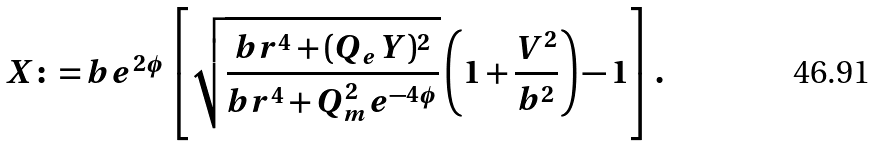<formula> <loc_0><loc_0><loc_500><loc_500>X \colon = b e ^ { 2 \phi } \left [ \sqrt { \frac { b r ^ { 4 } + ( Q _ { e } Y ) ^ { 2 } } { b r ^ { 4 } + Q _ { m } ^ { 2 } e ^ { - 4 \phi } } } \left ( 1 + \frac { V ^ { 2 } } { b ^ { 2 } } \right ) - 1 \right ] .</formula> 